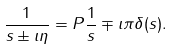<formula> <loc_0><loc_0><loc_500><loc_500>\frac { 1 } { s \pm \imath \eta } = P \frac { 1 } { s } \mp \imath \pi \delta ( s ) .</formula> 